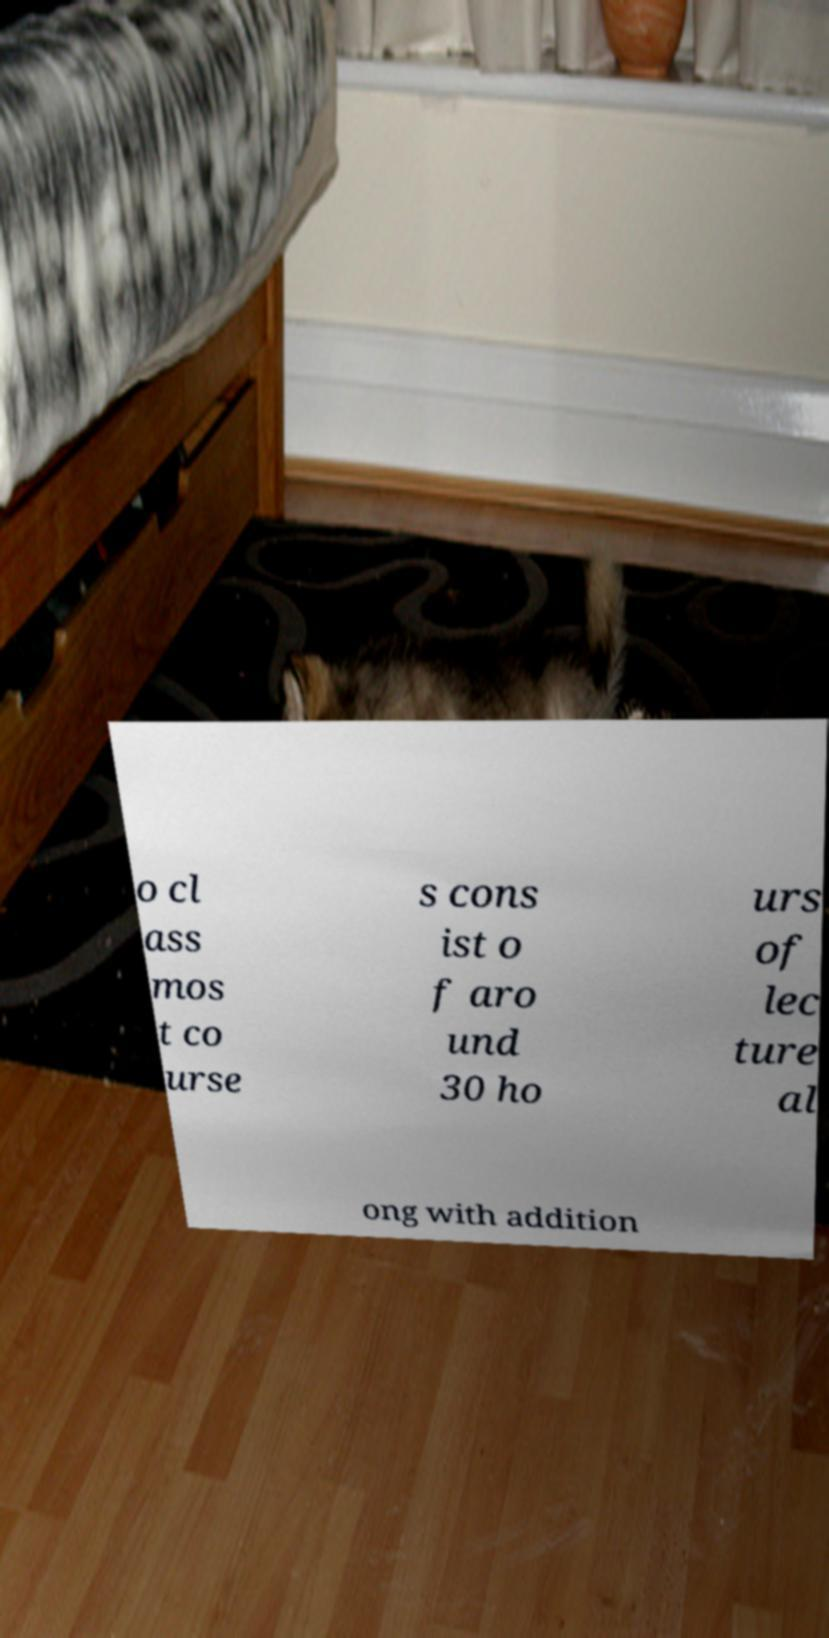Can you accurately transcribe the text from the provided image for me? o cl ass mos t co urse s cons ist o f aro und 30 ho urs of lec ture al ong with addition 